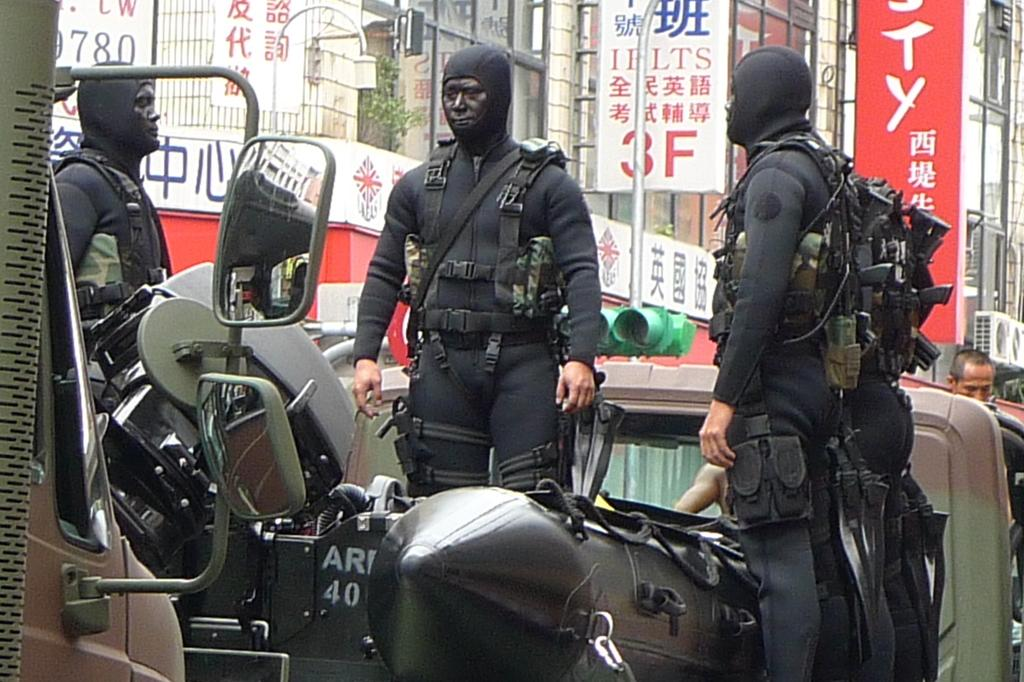What are the people in the image holding? The people in the image are carrying guns. What else can be seen in the image besides the people with guns? There are vehicles, buildings, poles, boards, and lights in the image. What type of brush is being used to create the popcorn in the image? There is no brush or popcorn present in the image. What is the reaction of the people in the image when they see the lights? The image does not depict any reactions of the people, so it cannot be determined how they might react to the lights. 